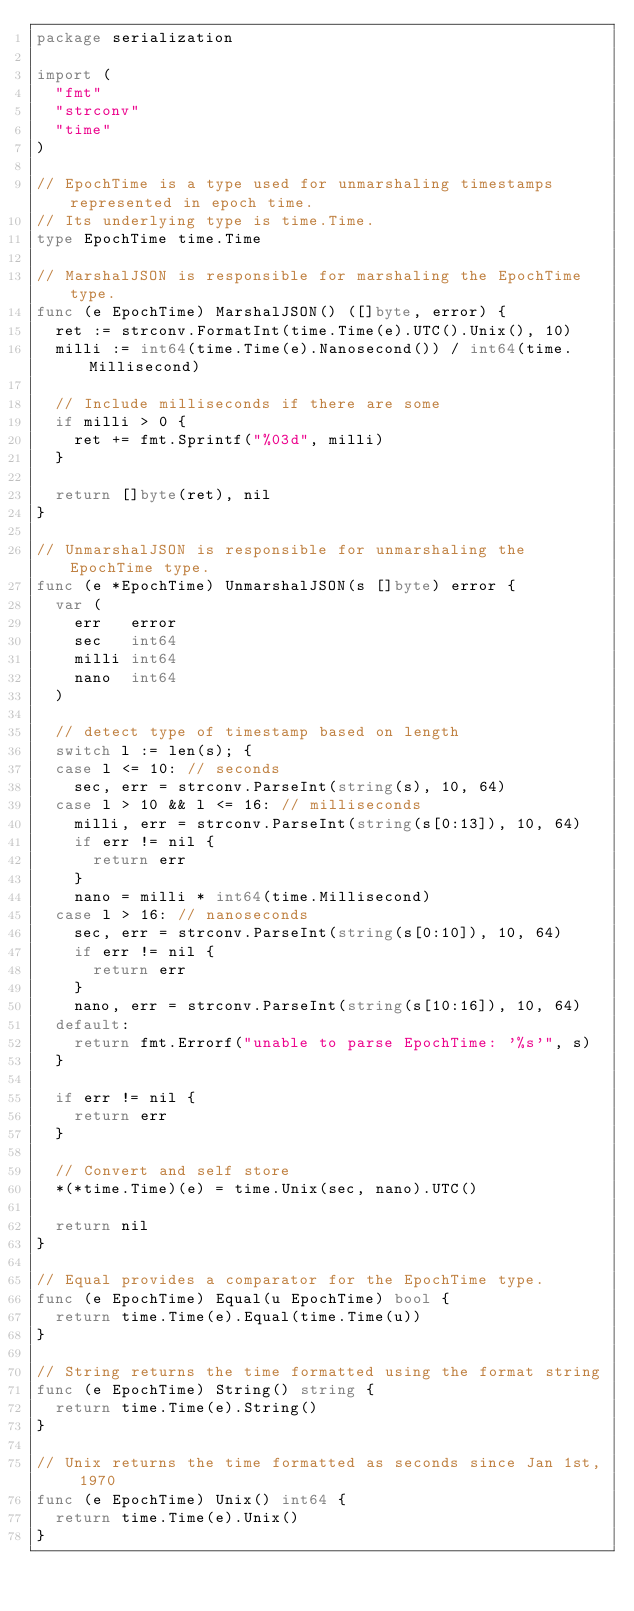Convert code to text. <code><loc_0><loc_0><loc_500><loc_500><_Go_>package serialization

import (
	"fmt"
	"strconv"
	"time"
)

// EpochTime is a type used for unmarshaling timestamps represented in epoch time.
// Its underlying type is time.Time.
type EpochTime time.Time

// MarshalJSON is responsible for marshaling the EpochTime type.
func (e EpochTime) MarshalJSON() ([]byte, error) {
	ret := strconv.FormatInt(time.Time(e).UTC().Unix(), 10)
	milli := int64(time.Time(e).Nanosecond()) / int64(time.Millisecond)

	// Include milliseconds if there are some
	if milli > 0 {
		ret += fmt.Sprintf("%03d", milli)
	}

	return []byte(ret), nil
}

// UnmarshalJSON is responsible for unmarshaling the EpochTime type.
func (e *EpochTime) UnmarshalJSON(s []byte) error {
	var (
		err   error
		sec   int64
		milli int64
		nano  int64
	)

	// detect type of timestamp based on length
	switch l := len(s); {
	case l <= 10: // seconds
		sec, err = strconv.ParseInt(string(s), 10, 64)
	case l > 10 && l <= 16: // milliseconds
		milli, err = strconv.ParseInt(string(s[0:13]), 10, 64)
		if err != nil {
			return err
		}
		nano = milli * int64(time.Millisecond)
	case l > 16: // nanoseconds
		sec, err = strconv.ParseInt(string(s[0:10]), 10, 64)
		if err != nil {
			return err
		}
		nano, err = strconv.ParseInt(string(s[10:16]), 10, 64)
	default:
		return fmt.Errorf("unable to parse EpochTime: '%s'", s)
	}

	if err != nil {
		return err
	}

	// Convert and self store
	*(*time.Time)(e) = time.Unix(sec, nano).UTC()

	return nil
}

// Equal provides a comparator for the EpochTime type.
func (e EpochTime) Equal(u EpochTime) bool {
	return time.Time(e).Equal(time.Time(u))
}

// String returns the time formatted using the format string
func (e EpochTime) String() string {
	return time.Time(e).String()
}

// Unix returns the time formatted as seconds since Jan 1st, 1970
func (e EpochTime) Unix() int64 {
	return time.Time(e).Unix()
}
</code> 